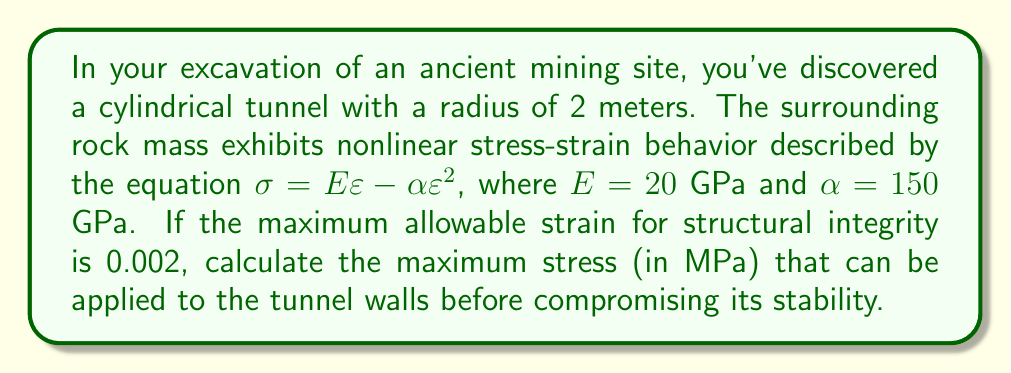Solve this math problem. To solve this problem, we'll follow these steps:

1) The given nonlinear stress-strain relationship is:
   $$\sigma = E\varepsilon - \alpha\varepsilon^2$$

2) We're given:
   $E = 20$ GPa = $20 \times 10^3$ MPa
   $\alpha = 150$ GPa = $150 \times 10^3$ MPa
   Maximum allowable strain, $\varepsilon_{max} = 0.002$

3) To find the maximum stress, we substitute $\varepsilon_{max}$ into the equation:
   $$\sigma_{max} = E\varepsilon_{max} - \alpha\varepsilon_{max}^2$$

4) Substituting the values:
   $$\sigma_{max} = (20 \times 10^3 \times 0.002) - (150 \times 10^3 \times 0.002^2)$$

5) Calculating:
   $$\sigma_{max} = 40 - 0.6 = 39.4 \text{ MPa}$$

Therefore, the maximum stress that can be applied to the tunnel walls before compromising its stability is 39.4 MPa.
Answer: 39.4 MPa 